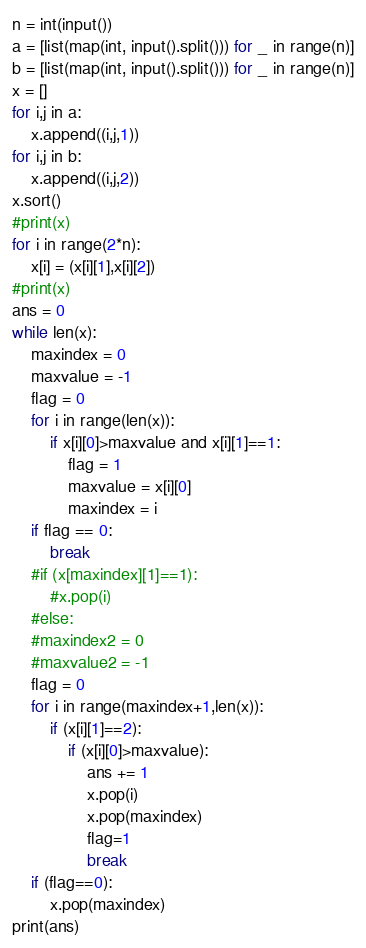Convert code to text. <code><loc_0><loc_0><loc_500><loc_500><_Python_>n = int(input())
a = [list(map(int, input().split())) for _ in range(n)]
b = [list(map(int, input().split())) for _ in range(n)]
x = []
for i,j in a:
    x.append((i,j,1))
for i,j in b:
    x.append((i,j,2))
x.sort()
#print(x)
for i in range(2*n):
    x[i] = (x[i][1],x[i][2])
#print(x)
ans = 0
while len(x):
    maxindex = 0
    maxvalue = -1
    flag = 0
    for i in range(len(x)):
        if x[i][0]>maxvalue and x[i][1]==1:
            flag = 1
            maxvalue = x[i][0]
            maxindex = i
    if flag == 0:
        break
    #if (x[maxindex][1]==1):
        #x.pop(i)
    #else:
    #maxindex2 = 0
    #maxvalue2 = -1
    flag = 0
    for i in range(maxindex+1,len(x)):
        if (x[i][1]==2):
            if (x[i][0]>maxvalue):
                ans += 1
                x.pop(i)
                x.pop(maxindex)
                flag=1
                break
    if (flag==0):
        x.pop(maxindex)
print(ans)</code> 